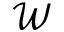Convert formula to latex. <formula><loc_0><loc_0><loc_500><loc_500>\mathcal { W }</formula> 